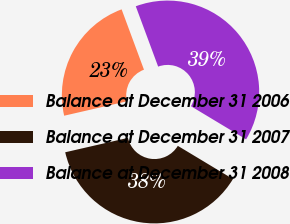Convert chart to OTSL. <chart><loc_0><loc_0><loc_500><loc_500><pie_chart><fcel>Balance at December 31 2006<fcel>Balance at December 31 2007<fcel>Balance at December 31 2008<nl><fcel>22.94%<fcel>37.79%<fcel>39.27%<nl></chart> 